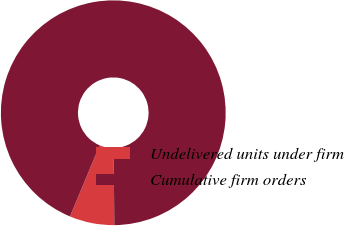Convert chart. <chart><loc_0><loc_0><loc_500><loc_500><pie_chart><fcel>Undelivered units under firm<fcel>Cumulative firm orders<nl><fcel>6.44%<fcel>93.56%<nl></chart> 